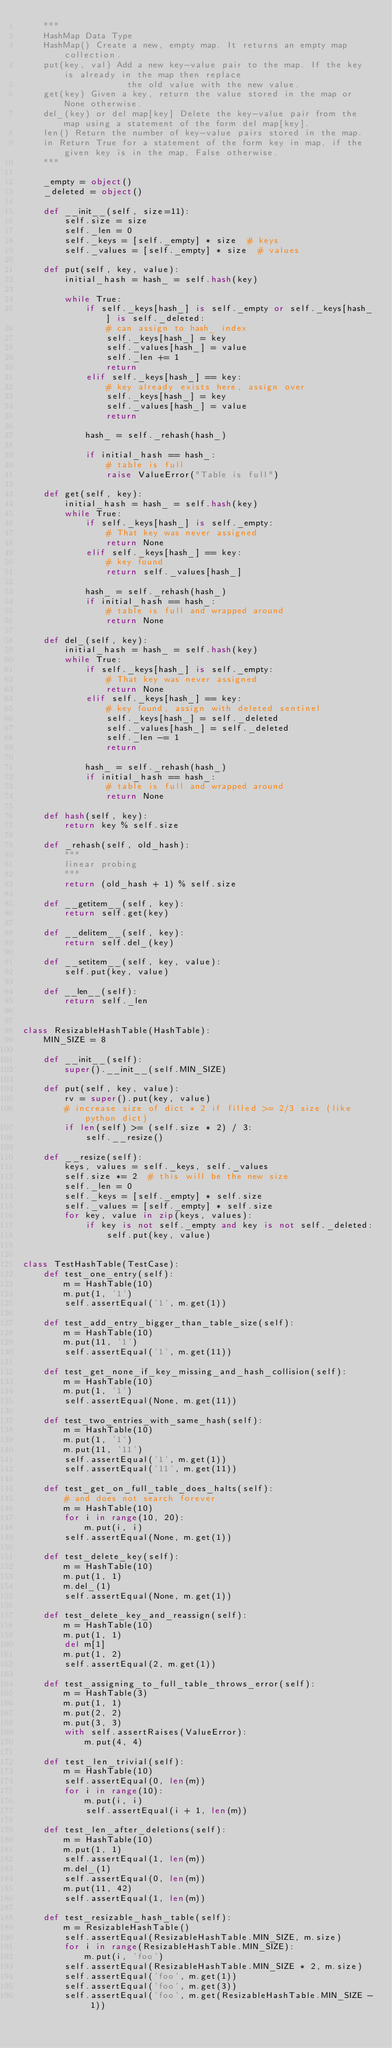Convert code to text. <code><loc_0><loc_0><loc_500><loc_500><_Python_>    """
    HashMap Data Type
    HashMap() Create a new, empty map. It returns an empty map collection.
    put(key, val) Add a new key-value pair to the map. If the key is already in the map then replace
                    the old value with the new value.
    get(key) Given a key, return the value stored in the map or None otherwise.
    del_(key) or del map[key] Delete the key-value pair from the map using a statement of the form del map[key].
    len() Return the number of key-value pairs stored in the map.
    in Return True for a statement of the form key in map, if the given key is in the map, False otherwise.
    """

    _empty = object()
    _deleted = object()

    def __init__(self, size=11):
        self.size = size
        self._len = 0
        self._keys = [self._empty] * size  # keys
        self._values = [self._empty] * size  # values

    def put(self, key, value):
        initial_hash = hash_ = self.hash(key)

        while True:
            if self._keys[hash_] is self._empty or self._keys[hash_] is self._deleted:
                # can assign to hash_ index
                self._keys[hash_] = key
                self._values[hash_] = value
                self._len += 1
                return
            elif self._keys[hash_] == key:
                # key already exists here, assign over
                self._keys[hash_] = key
                self._values[hash_] = value
                return

            hash_ = self._rehash(hash_)

            if initial_hash == hash_:
                # table is full
                raise ValueError("Table is full")

    def get(self, key):
        initial_hash = hash_ = self.hash(key)
        while True:
            if self._keys[hash_] is self._empty:
                # That key was never assigned
                return None
            elif self._keys[hash_] == key:
                # key found
                return self._values[hash_]

            hash_ = self._rehash(hash_)
            if initial_hash == hash_:
                # table is full and wrapped around
                return None

    def del_(self, key):
        initial_hash = hash_ = self.hash(key)
        while True:
            if self._keys[hash_] is self._empty:
                # That key was never assigned
                return None
            elif self._keys[hash_] == key:
                # key found, assign with deleted sentinel
                self._keys[hash_] = self._deleted
                self._values[hash_] = self._deleted
                self._len -= 1
                return

            hash_ = self._rehash(hash_)
            if initial_hash == hash_:
                # table is full and wrapped around
                return None

    def hash(self, key):
        return key % self.size

    def _rehash(self, old_hash):
        """
        linear probing
        """
        return (old_hash + 1) % self.size

    def __getitem__(self, key):
        return self.get(key)

    def __delitem__(self, key):
        return self.del_(key)

    def __setitem__(self, key, value):
        self.put(key, value)

    def __len__(self):
        return self._len


class ResizableHashTable(HashTable):
    MIN_SIZE = 8

    def __init__(self):
        super().__init__(self.MIN_SIZE)

    def put(self, key, value):
        rv = super().put(key, value)
        # increase size of dict * 2 if filled >= 2/3 size (like python dict)
        if len(self) >= (self.size * 2) / 3:
            self.__resize()

    def __resize(self):
        keys, values = self._keys, self._values
        self.size *= 2  # this will be the new size
        self._len = 0
        self._keys = [self._empty] * self.size
        self._values = [self._empty] * self.size
        for key, value in zip(keys, values):
            if key is not self._empty and key is not self._deleted:
                self.put(key, value)


class TestHashTable(TestCase):
    def test_one_entry(self):
        m = HashTable(10)
        m.put(1, '1')
        self.assertEqual('1', m.get(1))

    def test_add_entry_bigger_than_table_size(self):
        m = HashTable(10)
        m.put(11, '1')
        self.assertEqual('1', m.get(11))

    def test_get_none_if_key_missing_and_hash_collision(self):
        m = HashTable(10)
        m.put(1, '1')
        self.assertEqual(None, m.get(11))

    def test_two_entries_with_same_hash(self):
        m = HashTable(10)
        m.put(1, '1')
        m.put(11, '11')
        self.assertEqual('1', m.get(1))
        self.assertEqual('11', m.get(11))

    def test_get_on_full_table_does_halts(self):
        # and does not search forever
        m = HashTable(10)
        for i in range(10, 20):
            m.put(i, i)
        self.assertEqual(None, m.get(1))

    def test_delete_key(self):
        m = HashTable(10)
        m.put(1, 1)
        m.del_(1)
        self.assertEqual(None, m.get(1))

    def test_delete_key_and_reassign(self):
        m = HashTable(10)
        m.put(1, 1)
        del m[1]
        m.put(1, 2)
        self.assertEqual(2, m.get(1))

    def test_assigning_to_full_table_throws_error(self):
        m = HashTable(3)
        m.put(1, 1)
        m.put(2, 2)
        m.put(3, 3)
        with self.assertRaises(ValueError):
            m.put(4, 4)

    def test_len_trivial(self):
        m = HashTable(10)
        self.assertEqual(0, len(m))
        for i in range(10):
            m.put(i, i)
            self.assertEqual(i + 1, len(m))

    def test_len_after_deletions(self):
        m = HashTable(10)
        m.put(1, 1)
        self.assertEqual(1, len(m))
        m.del_(1)
        self.assertEqual(0, len(m))
        m.put(11, 42)
        self.assertEqual(1, len(m))

    def test_resizable_hash_table(self):
        m = ResizableHashTable()
        self.assertEqual(ResizableHashTable.MIN_SIZE, m.size)
        for i in range(ResizableHashTable.MIN_SIZE):
            m.put(i, 'foo')
        self.assertEqual(ResizableHashTable.MIN_SIZE * 2, m.size)
        self.assertEqual('foo', m.get(1))
        self.assertEqual('foo', m.get(3))
        self.assertEqual('foo', m.get(ResizableHashTable.MIN_SIZE - 1))
</code> 